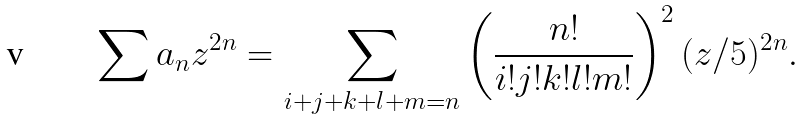Convert formula to latex. <formula><loc_0><loc_0><loc_500><loc_500>\sum a _ { n } z ^ { 2 n } = \sum _ { i + j + k + l + m = n } \left ( \frac { n ! } { i ! j ! k ! l ! m ! } \right ) ^ { 2 } ( z / 5 ) ^ { 2 n } .</formula> 